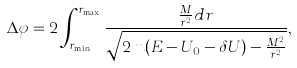Convert formula to latex. <formula><loc_0><loc_0><loc_500><loc_500>\Delta \varphi = 2 \int ^ { r _ { \max } } _ { r _ { \min } } \frac { \frac { M } { r ^ { 2 } } d r } { \sqrt { 2 m ( E - U _ { 0 } - \delta U ) - \frac { M ^ { 2 } } { r ^ { 2 } } } } ,</formula> 